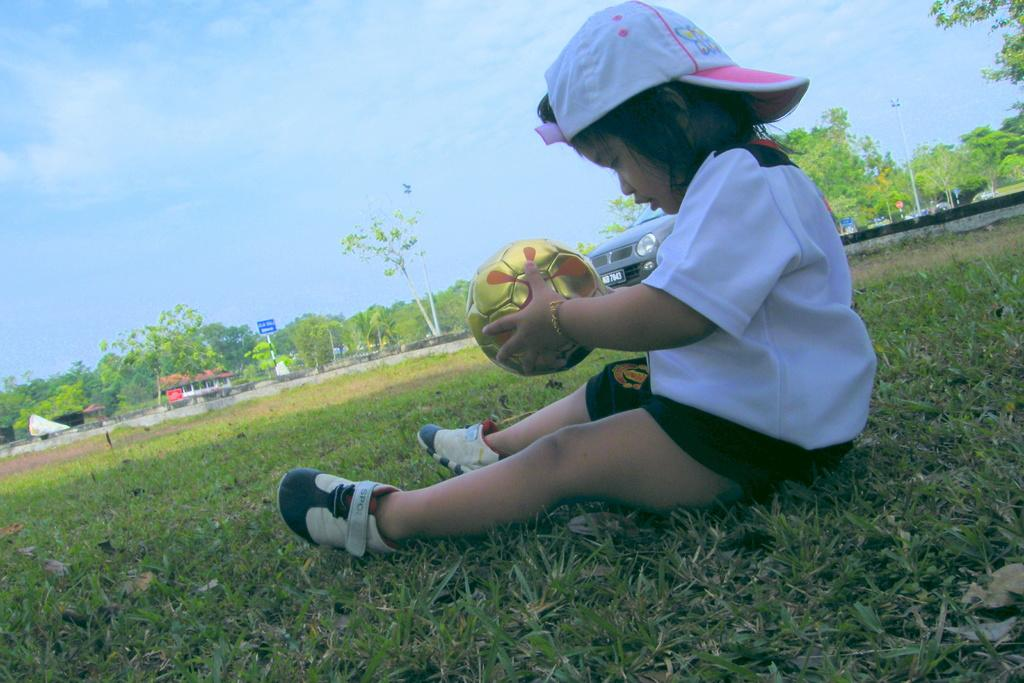Who is the main subject in the image? There is a girl in the image. What is the girl doing in the image? The girl is sitting on the grass. What is the girl holding in her hands? The girl is holding a ball in her hands. What can be seen in the background of the image? There are trees, a house, a sign board, a car, and a pole in the background of the image. What type of food is the girl attempting to cook in the image? There is no indication in the image that the girl is cooking or attempting to cook any food. 